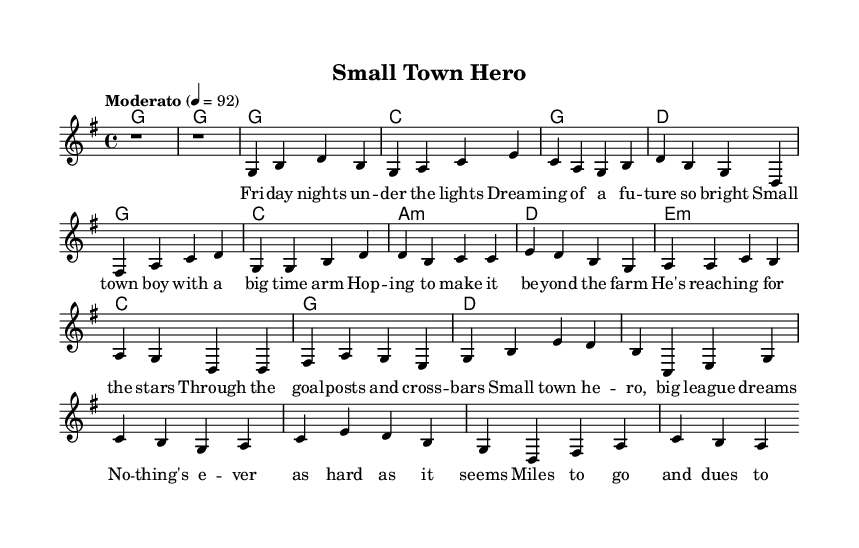What is the key signature of this music? The key signature indicates the sharps or flats that apply throughout the piece. In this score, it shows a single sharp, which corresponds to G major.
Answer: G major What is the time signature of this music? The time signature indicates how many beats are in each measure. In this score, it shows a 4 over 4, meaning there are four beats in each measure.
Answer: 4/4 What is the tempo marking for this piece? The tempo marking indicates the speed of the piece. In this score, it states "Moderato" with a metronome marking of 4 equals 92, indicating a moderate pace.
Answer: Moderato, 4 = 92 How many measures are in the chorus section? To find the number of measures in the chorus, counting the sections labeled as chorus in the score shows there are four distinct measures for this part.
Answer: 4 What is the theme of the lyrics in this song? The lyrics suggest the narrative quality typical of folk music, focusing on the aspirations of a small-town athlete dreaming of a bigger future. The recurring themes in the transitions from verses to chorus showcase pursuit and determination aligned with athletic dreams.
Answer: Aspirations of a small-town athlete What type of harmony is used in the chorus? The chords labeled in the chorus section reflect a common pop-folk harmony. Specifically, the progression shows that it starts with G major, moves to C major, and ends with D major, which is typical for a folk song.
Answer: G, C, A minor, D How does the bridge function in the overall structure of the song? The bridge provides a contrasting section that adds emotional depth and builds up to the final chorus. It shifts the focus from the main narrative to the challenges faced by the athlete, enhancing the storytelling common in folk music.
Answer: Adds emotional depth and contrast 